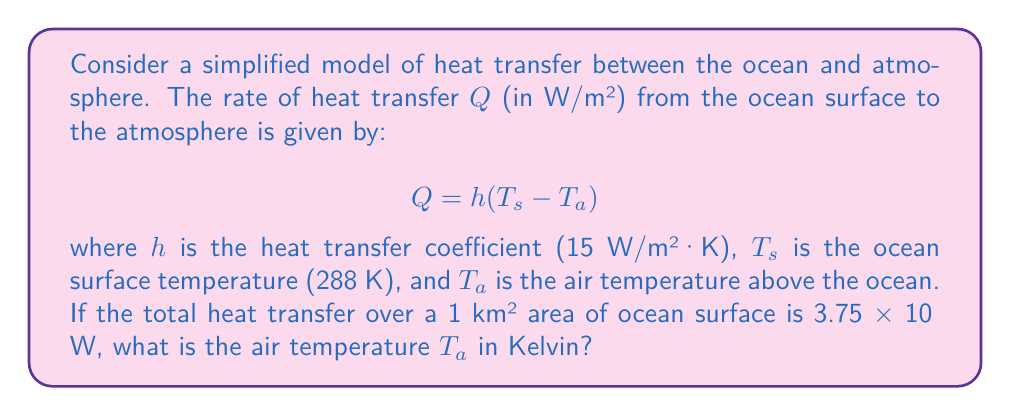Can you solve this math problem? Let's approach this step-by-step:

1) We're given the heat transfer equation: $Q = h(T_s - T_a)$

2) We know the following values:
   $h = 15$ W/m²·K
   $T_s = 288$ K
   Area = 1 km² = 1,000,000 m²
   Total heat transfer = 3.75 × 10⁶ W

3) First, we need to find $Q$ (heat transfer rate per square meter):
   $Q = \frac{\text{Total heat transfer}}{\text{Area}} = \frac{3.75 \times 10^6\text{ W}}{1,000,000\text{ m}^2} = 3.75$ W/m²

4) Now we can substitute this into our equation:
   $3.75 = 15(288 - T_a)$

5) Solve for $T_a$:
   $\frac{3.75}{15} = 288 - T_a$
   $0.25 = 288 - T_a$
   $T_a = 288 - 0.25 = 287.75$ K

Therefore, the air temperature $T_a$ is 287.75 K.
Answer: 287.75 K 